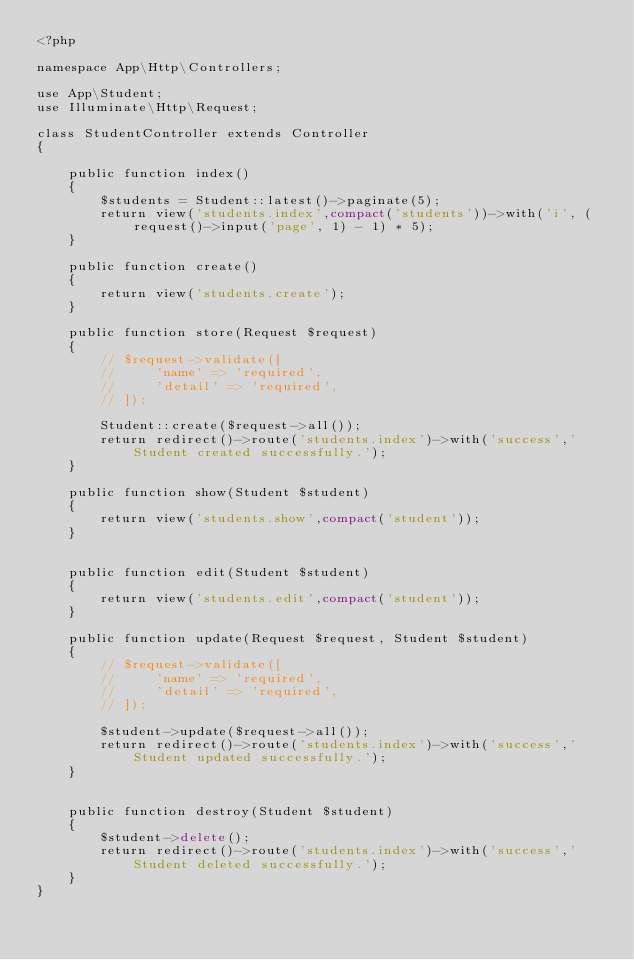Convert code to text. <code><loc_0><loc_0><loc_500><loc_500><_PHP_><?php

namespace App\Http\Controllers;

use App\Student;
use Illuminate\Http\Request;

class StudentController extends Controller
{

    public function index()
    {
        $students = Student::latest()->paginate(5);
        return view('students.index',compact('students'))->with('i', (request()->input('page', 1) - 1) * 5);
    }

    public function create()
    {
        return view('students.create');
    }

    public function store(Request $request)
    {
        // $request->validate([
        //     'name' => 'required',
        //     'detail' => 'required',
        // ]);

        Student::create($request->all());
        return redirect()->route('students.index')->with('success','Student created successfully.');
    }

    public function show(Student $student)
    {
        return view('students.show',compact('student'));
    }


    public function edit(Student $student)
    {
        return view('students.edit',compact('student'));
    }

    public function update(Request $request, Student $student)
    {
        // $request->validate([
        //     'name' => 'required',
        //     'detail' => 'required',
        // ]);

        $student->update($request->all());
        return redirect()->route('students.index')->with('success','Student updated successfully.');
    }


    public function destroy(Student $student)
    {
        $student->delete();
        return redirect()->route('students.index')->with('success','Student deleted successfully.');
    }
}
</code> 